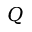Convert formula to latex. <formula><loc_0><loc_0><loc_500><loc_500>Q</formula> 